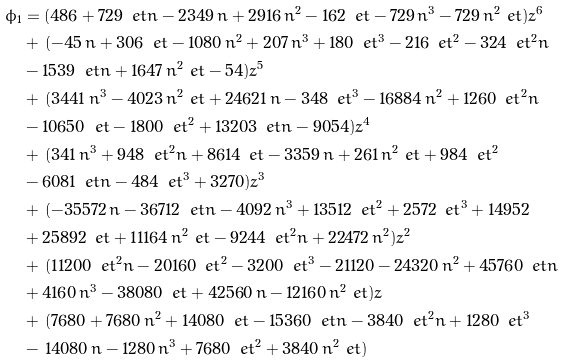<formula> <loc_0><loc_0><loc_500><loc_500>\phi _ { 1 } & = ( 4 8 6 + 7 2 9 \, \ e t n - 2 3 4 9 \, n + 2 9 1 6 \, { n } ^ { 2 } - 1 6 2 \, \ e t - 7 2 9 \, { n } ^ { 3 } - 7 2 9 \, { n } ^ { 2 } \ e t ) { z } ^ { 6 } \\ & + \, ( - 4 5 \, n + 3 0 6 \, \ e t - 1 0 8 0 \, { n } ^ { 2 } + 2 0 7 \, { n } ^ { 3 } + 1 8 0 \, { \ e t } ^ { 3 } - 2 1 6 \, { \ e t } ^ { 2 } - 3 2 4 \, { \ e t } ^ { 2 } n \\ & - 1 5 3 9 \, \ e t n + 1 6 4 7 \, { n } ^ { 2 } \ e t - 5 4 ) { z } ^ { 5 } \\ & + \, ( 3 4 4 1 \, { n } ^ { 3 } - 4 0 2 3 \, { n } ^ { 2 } \ e t + 2 4 6 2 1 \, n - 3 4 8 \, { \ e t } ^ { 3 } - 1 6 8 8 4 \, { n } ^ { 2 } + 1 2 6 0 \, { \ e t } ^ { 2 } n \\ & - 1 0 6 5 0 \, \ e t - 1 8 0 0 \, { \ e t } ^ { 2 } + 1 3 2 0 3 \, \ e t n - 9 0 5 4 ) { z } ^ { 4 } \\ & + \, ( 3 4 1 \, { n } ^ { 3 } + 9 4 8 \, { \ e t } ^ { 2 } n + 8 6 1 4 \, \ e t - 3 3 5 9 \, n + 2 6 1 \, { n } ^ { 2 } \ e t + 9 8 4 \, { \ e t } ^ { 2 } \\ & - 6 0 8 1 \, \ e t n - 4 8 4 \, { \ e t } ^ { 3 } + 3 2 7 0 ) { z } ^ { 3 } \\ & + \, ( - 3 5 5 7 2 \, n - 3 6 7 1 2 \, \ e t n - 4 0 9 2 \, { n } ^ { 3 } + 1 3 5 1 2 \, { \ e t } ^ { 2 } + 2 5 7 2 \, { \ e t } ^ { 3 } + 1 4 9 5 2 \\ & + 2 5 8 9 2 \, \ e t + 1 1 1 6 4 \, { n } ^ { 2 } \ e t - 9 2 4 4 \, { \ e t } ^ { 2 } n + 2 2 4 7 2 \, { n } ^ { 2 } ) { z } ^ { 2 } \\ & + \, ( 1 1 2 0 0 \, { \ e t } ^ { 2 } n - 2 0 1 6 0 \, { \ e t } ^ { 2 } - 3 2 0 0 \, { \ e t } ^ { 3 } - 2 1 1 2 0 - 2 4 3 2 0 \, { n } ^ { 2 } + 4 5 7 6 0 \, \ e t n \\ & + 4 1 6 0 \, { n } ^ { 3 } - 3 8 0 8 0 \, \ e t + 4 2 5 6 0 \, n - 1 2 1 6 0 \, { n } ^ { 2 } \ e t ) z \\ & + \, ( 7 6 8 0 + 7 6 8 0 \, { n } ^ { 2 } + 1 4 0 8 0 \, \ e t - 1 5 3 6 0 \, \ e t n - 3 8 4 0 \, { \ e t } ^ { 2 } n + 1 2 8 0 \, { \ e t } ^ { 3 } \\ & - \, 1 4 0 8 0 \, n - 1 2 8 0 \, { n } ^ { 3 } + 7 6 8 0 \, { \ e t } ^ { 2 } + 3 8 4 0 \, { n } ^ { 2 } \ e t )</formula> 